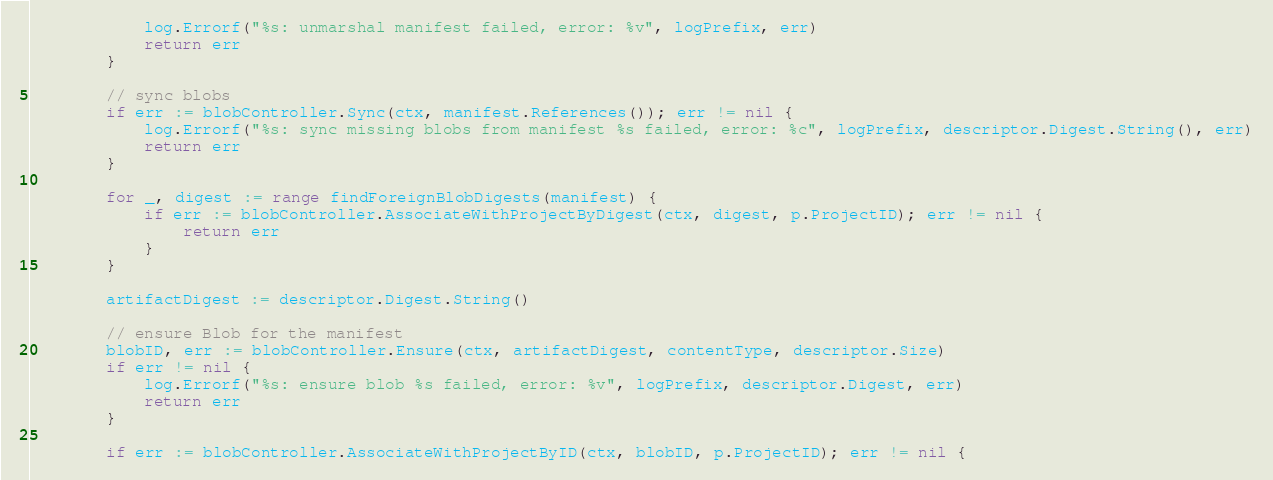Convert code to text. <code><loc_0><loc_0><loc_500><loc_500><_Go_>			log.Errorf("%s: unmarshal manifest failed, error: %v", logPrefix, err)
			return err
		}

		// sync blobs
		if err := blobController.Sync(ctx, manifest.References()); err != nil {
			log.Errorf("%s: sync missing blobs from manifest %s failed, error: %c", logPrefix, descriptor.Digest.String(), err)
			return err
		}

		for _, digest := range findForeignBlobDigests(manifest) {
			if err := blobController.AssociateWithProjectByDigest(ctx, digest, p.ProjectID); err != nil {
				return err
			}
		}

		artifactDigest := descriptor.Digest.String()

		// ensure Blob for the manifest
		blobID, err := blobController.Ensure(ctx, artifactDigest, contentType, descriptor.Size)
		if err != nil {
			log.Errorf("%s: ensure blob %s failed, error: %v", logPrefix, descriptor.Digest, err)
			return err
		}

		if err := blobController.AssociateWithProjectByID(ctx, blobID, p.ProjectID); err != nil {</code> 